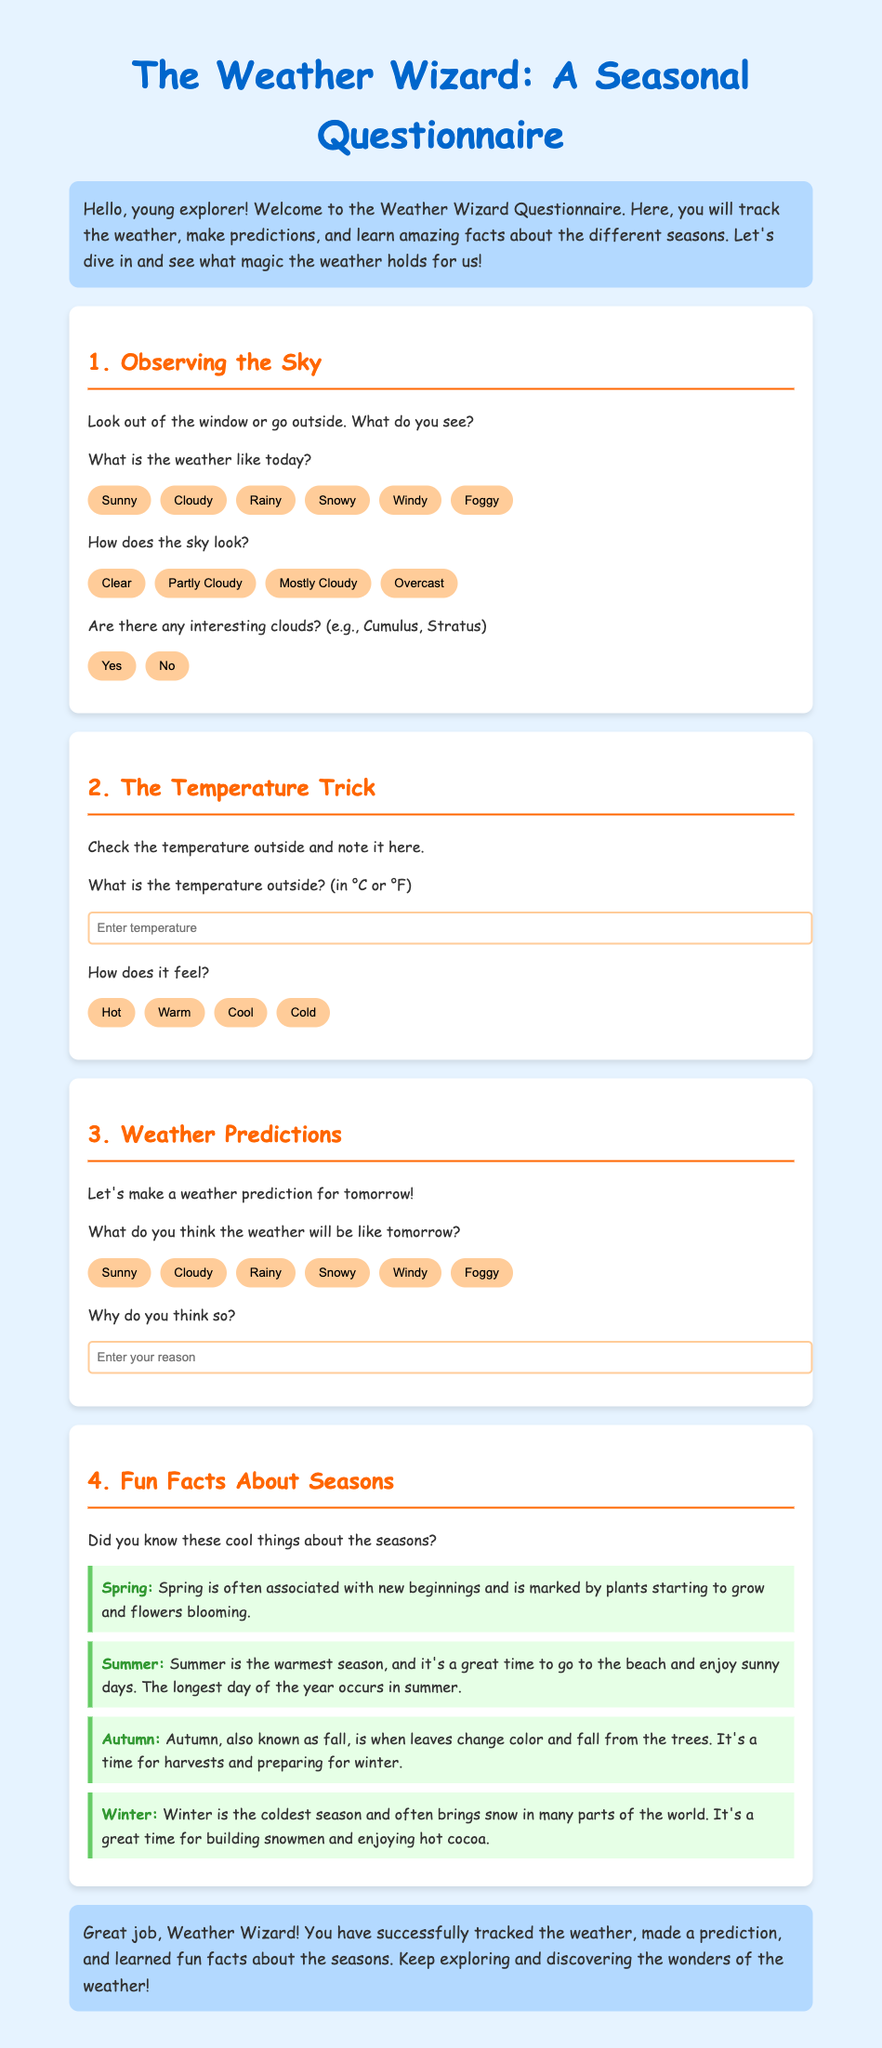What is the title of the document? The title is displayed prominently at the top of the document, indicating the focus of the content.
Answer: The Weather Wizard Questionnaire What season is associated with new beginnings? This information is provided in the fun facts section about spring.
Answer: Spring What types of weather can you predict for tomorrow? The document lists various options for weather predictions that can be selected.
Answer: Sunny, Cloudy, Rainy, Snowy, Windy, Foggy What does the weather feel like if it's 30 degrees Celsius? This question relates to how temperatures are subjectively experienced, which can be captured in the questionnaire section.
Answer: Hot How does the document suggest making a weather prediction? The questionnaire section provides a specific prompt for making predictions about tomorrow's weather.
Answer: Select a weather type What type of clouds can be observed according to the options? The options offered in the questionnaire allow for identifying types of clouds present.
Answer: Cumulus, Stratus What is recommended to drink during winter? The document mentions enjoyable activities during winter which indirectly implies something cozy.
Answer: Hot cocoa What color is the heading for the fun facts section? The fun facts section is visually distinct with a particular color highlighting its importance.
Answer: Orange 